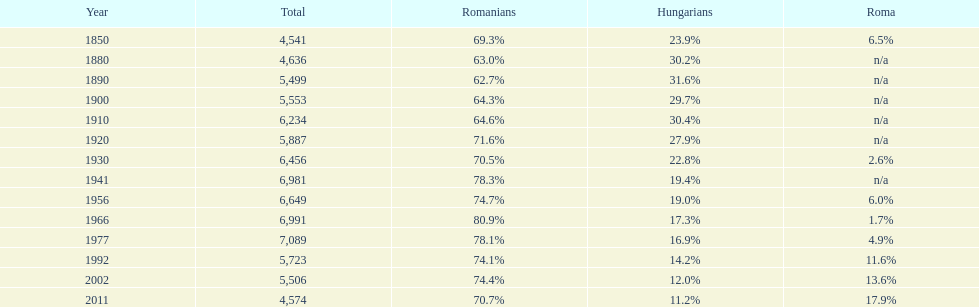In which year did the largest share of hungarians occur? 1890. 